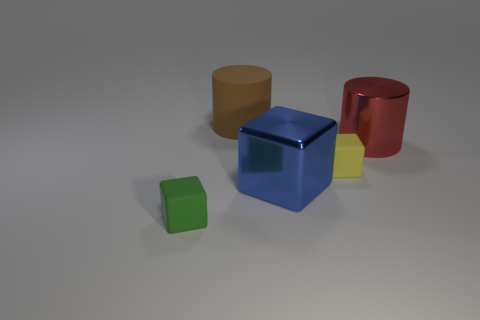There is a red thing that is the same size as the matte cylinder; what is it made of?
Your answer should be compact. Metal. What is the size of the thing to the left of the big rubber cylinder?
Your answer should be compact. Small. The red shiny object is what size?
Your answer should be very brief. Large. There is a brown matte cylinder; is its size the same as the shiny thing in front of the big red shiny cylinder?
Your answer should be compact. Yes. What is the color of the tiny rubber thing in front of the small thing that is to the right of the blue cube?
Your answer should be very brief. Green. Is the number of big matte cylinders that are to the left of the tiny yellow matte object the same as the number of metal cylinders in front of the large block?
Your answer should be compact. No. Are the object on the left side of the big brown cylinder and the big brown object made of the same material?
Make the answer very short. Yes. There is a rubber thing that is both in front of the big red metallic thing and left of the big blue object; what color is it?
Keep it short and to the point. Green. There is a small matte cube to the right of the tiny green block; how many big objects are right of it?
Provide a short and direct response. 1. There is another tiny object that is the same shape as the small yellow object; what is it made of?
Your answer should be compact. Rubber. 